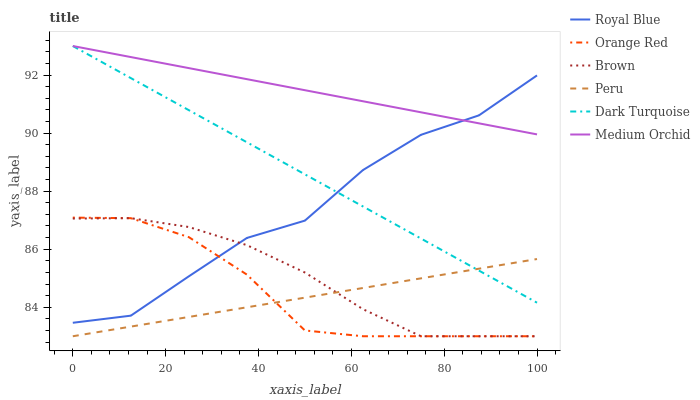Does Peru have the minimum area under the curve?
Answer yes or no. Yes. Does Medium Orchid have the maximum area under the curve?
Answer yes or no. Yes. Does Dark Turquoise have the minimum area under the curve?
Answer yes or no. No. Does Dark Turquoise have the maximum area under the curve?
Answer yes or no. No. Is Peru the smoothest?
Answer yes or no. Yes. Is Royal Blue the roughest?
Answer yes or no. Yes. Is Dark Turquoise the smoothest?
Answer yes or no. No. Is Dark Turquoise the roughest?
Answer yes or no. No. Does Brown have the lowest value?
Answer yes or no. Yes. Does Dark Turquoise have the lowest value?
Answer yes or no. No. Does Medium Orchid have the highest value?
Answer yes or no. Yes. Does Royal Blue have the highest value?
Answer yes or no. No. Is Orange Red less than Dark Turquoise?
Answer yes or no. Yes. Is Medium Orchid greater than Peru?
Answer yes or no. Yes. Does Orange Red intersect Royal Blue?
Answer yes or no. Yes. Is Orange Red less than Royal Blue?
Answer yes or no. No. Is Orange Red greater than Royal Blue?
Answer yes or no. No. Does Orange Red intersect Dark Turquoise?
Answer yes or no. No. 